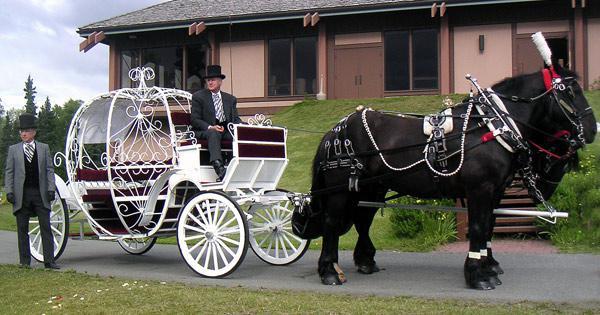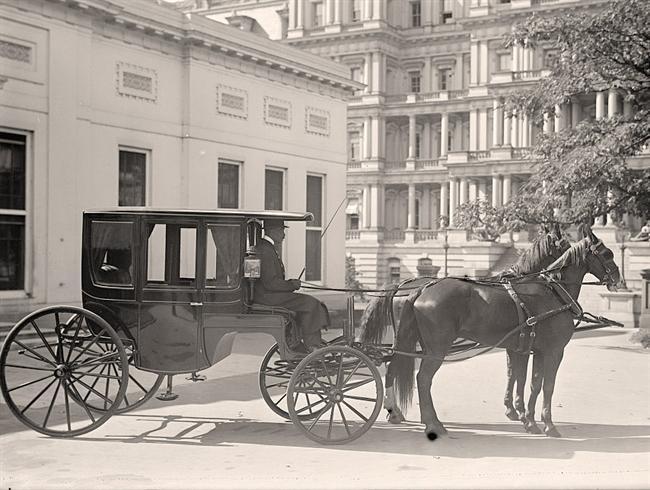The first image is the image on the left, the second image is the image on the right. Considering the images on both sides, is "The white carriage is being pulled by a black horse." valid? Answer yes or no. Yes. 